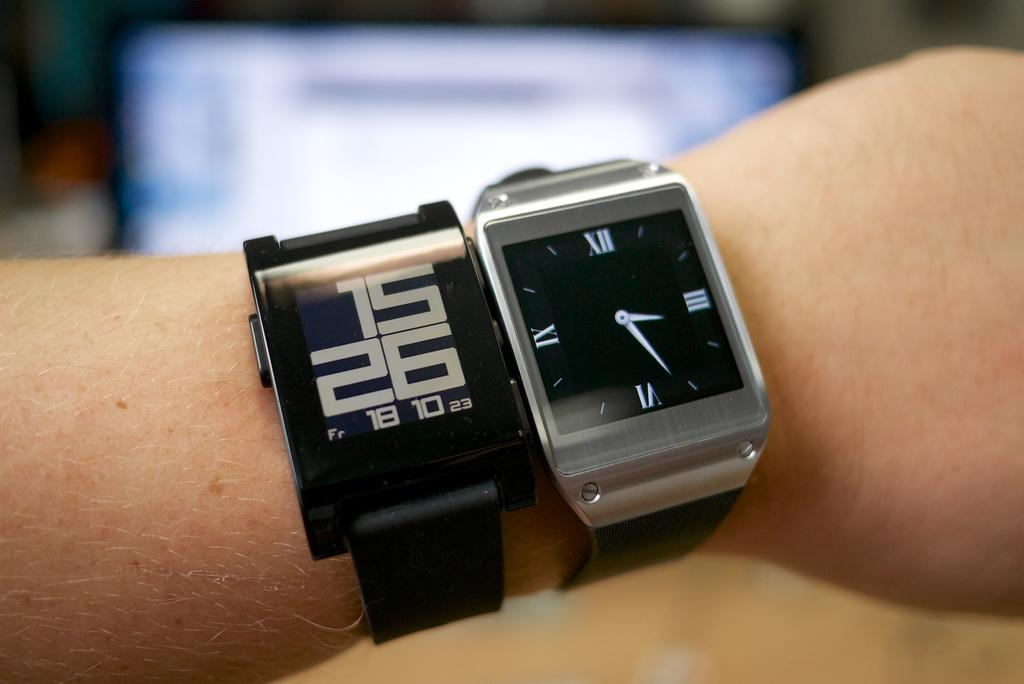<image>
Provide a brief description of the given image. a watch that has the number 26 on the wristband 